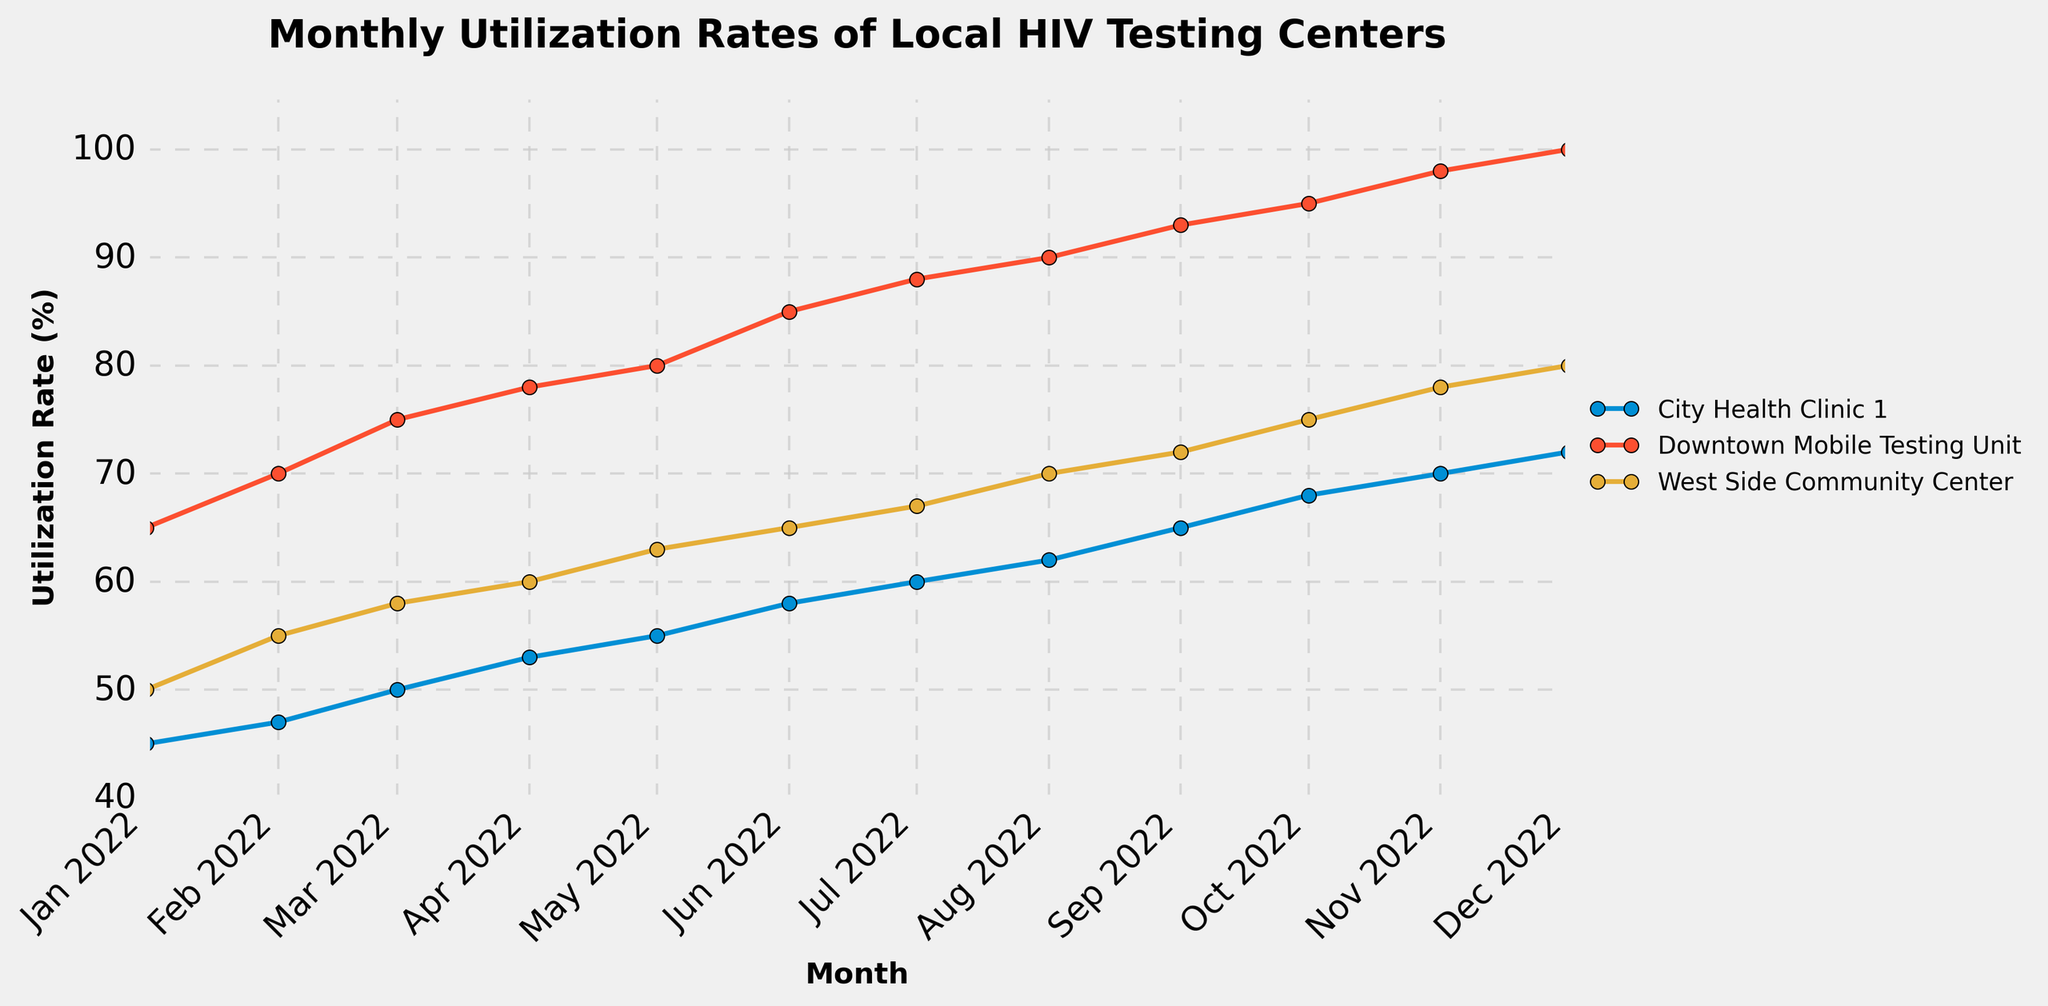What is the highest utilization rate recorded in the figure? The highest utilization rate can be found by looking at the y-axis and finding the highest point at which a line peaks. The Downtown Mobile Testing Unit peaks at 100% in December 2022.
Answer: 100% Which testing center had the lowest utilization rate in January 2022? To find the testing center with the lowest rate in January 2022, look at the data points for the starting month across all testing centers. City Health Clinic 1 had a utilization rate of 45%, which is the lowest among all centers in January 2022.
Answer: City Health Clinic 1 How did the utilization rate for Downtown Mobile Testing Unit change from January 2022 to December 2022? To determine the change in utilization rate, compare the two data points from January 2022 and December 2022 for the Downtown Mobile Testing Unit. The utilization rate increased from 65% to 100%.
Answer: Increased by 35% By how much did the utilization rate for the West Side Community Center increase from June to December 2022? Identify the rates for West Side Community Center in June and December 2022 (65% and 80%, respectively), then subtract the June rate from the December rate (80% - 65%).
Answer: Increased by 15% What is the average utilization rate for City Health Clinic 1 over the entire year? Sum the utilization rates of City Health Clinic 1 for all months (45 + 47 + 50 + 53 + 55 + 58 + 60 + 62 + 65 + 68 + 70 + 72 = 705) and divide by the number of months (705 / 12).
Answer: 58.75% Which testing center had the most consistent increase in utilization rate throughout the year? Examine all the plotted lines to see which one shows the most consistent upward trend. The Downtown Mobile Testing Unit shows a consistent increase without any dips through all months.
Answer: Downtown Mobile Testing Unit By comparing the end value of November 2022 for the Downtown Mobile Testing Unit and West Side Community Center, which one had a higher utilization rate? Check the data points for both centers in November 2022. The Downtown Mobile Testing Unit had a utilization rate of 98%, while the West Side Community Center had 78%.
Answer: Downtown Mobile Testing Unit What is the trend of the utilization rates for all centers? Look at the general direction in which the lines are moving for all centers. All three centers show an upward trend in utilization rates over the months.
Answer: Upward trend What month saw the first time the City Health Clinic 1 reached a 60% utilization rate? Trace the line for City Health Clinic 1 to see when it first hits the 60% mark. City Health Clinic 1 first reaches 60% in July 2022.
Answer: July 2022 